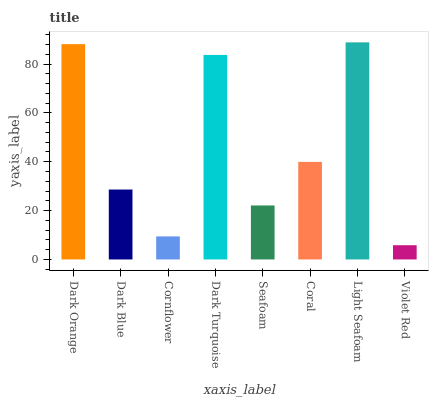Is Dark Blue the minimum?
Answer yes or no. No. Is Dark Blue the maximum?
Answer yes or no. No. Is Dark Orange greater than Dark Blue?
Answer yes or no. Yes. Is Dark Blue less than Dark Orange?
Answer yes or no. Yes. Is Dark Blue greater than Dark Orange?
Answer yes or no. No. Is Dark Orange less than Dark Blue?
Answer yes or no. No. Is Coral the high median?
Answer yes or no. Yes. Is Dark Blue the low median?
Answer yes or no. Yes. Is Dark Orange the high median?
Answer yes or no. No. Is Violet Red the low median?
Answer yes or no. No. 